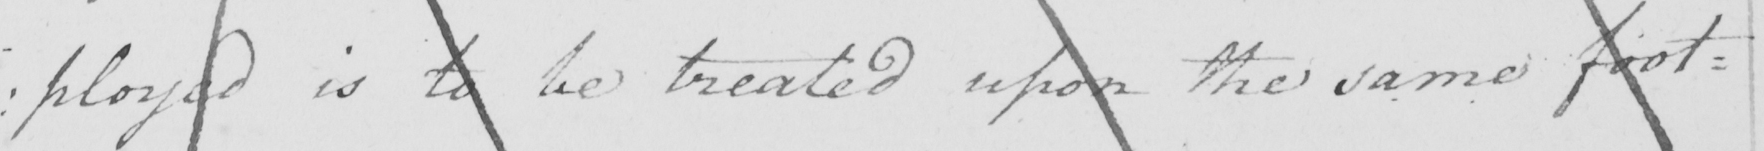What text is written in this handwritten line? : ployed is to be treated upon the same foot= 